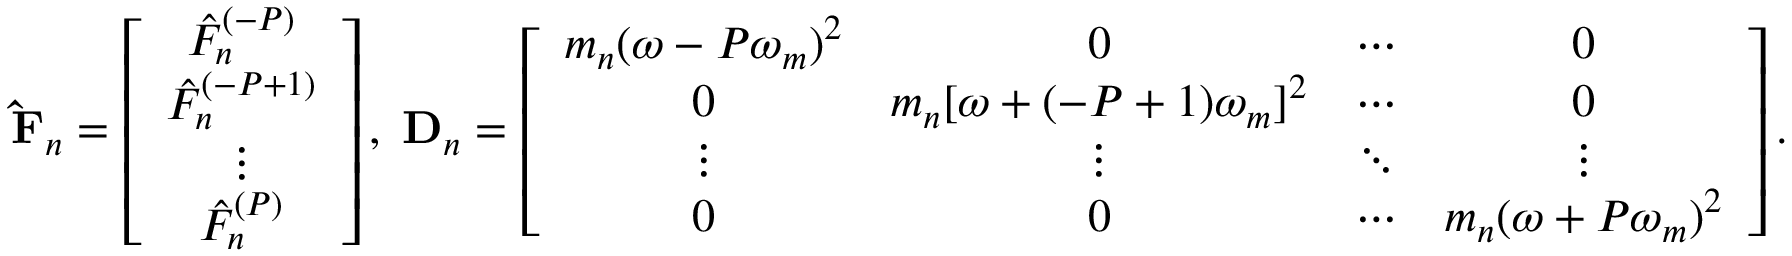Convert formula to latex. <formula><loc_0><loc_0><loc_500><loc_500>\hat { F } _ { n } = \left [ \begin{array} { c } { \hat { F } _ { n } ^ { ( - P ) } } \\ { \hat { F } _ { n } ^ { ( - P + 1 ) } } \\ { \vdots } \\ { \hat { F } _ { n } ^ { ( P ) } } \end{array} \right ] , \, D _ { n } = \left [ \begin{array} { c c c c } { m _ { n } ( \omega - P \omega _ { m } ) ^ { 2 } } & { 0 } & { \cdots } & { 0 } \\ { 0 } & { m _ { n } [ \omega + ( - P + 1 ) \omega _ { m } ] ^ { 2 } } & { \cdots } & { 0 } \\ { \vdots } & { \vdots } & { \ddots } & { \vdots } \\ { 0 } & { 0 } & { \cdots } & { m _ { n } ( \omega + P \omega _ { m } ) ^ { 2 } } \end{array} \right ] .</formula> 